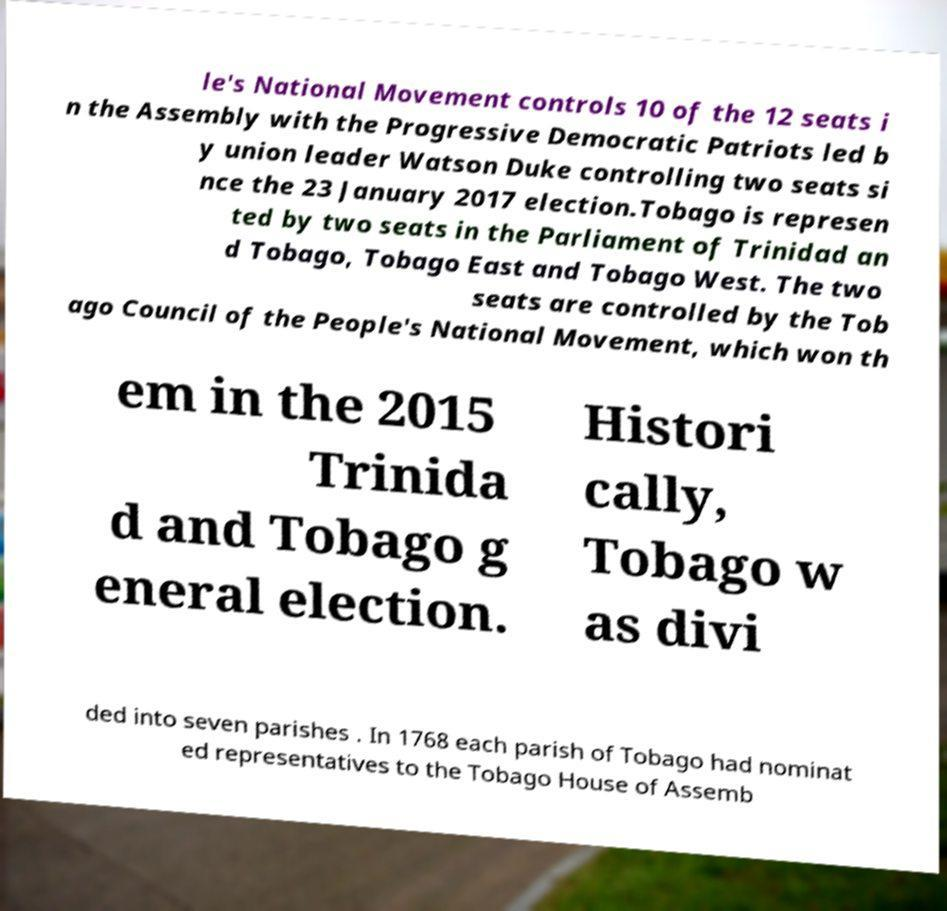There's text embedded in this image that I need extracted. Can you transcribe it verbatim? le's National Movement controls 10 of the 12 seats i n the Assembly with the Progressive Democratic Patriots led b y union leader Watson Duke controlling two seats si nce the 23 January 2017 election.Tobago is represen ted by two seats in the Parliament of Trinidad an d Tobago, Tobago East and Tobago West. The two seats are controlled by the Tob ago Council of the People's National Movement, which won th em in the 2015 Trinida d and Tobago g eneral election. Histori cally, Tobago w as divi ded into seven parishes . In 1768 each parish of Tobago had nominat ed representatives to the Tobago House of Assemb 